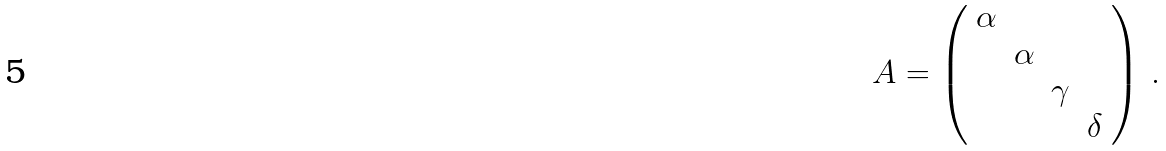Convert formula to latex. <formula><loc_0><loc_0><loc_500><loc_500>A = \left ( \begin{array} { c c c c } \alpha & & & \\ & \alpha & & \\ & & \gamma & \\ & & & \delta \end{array} \right ) \, .</formula> 